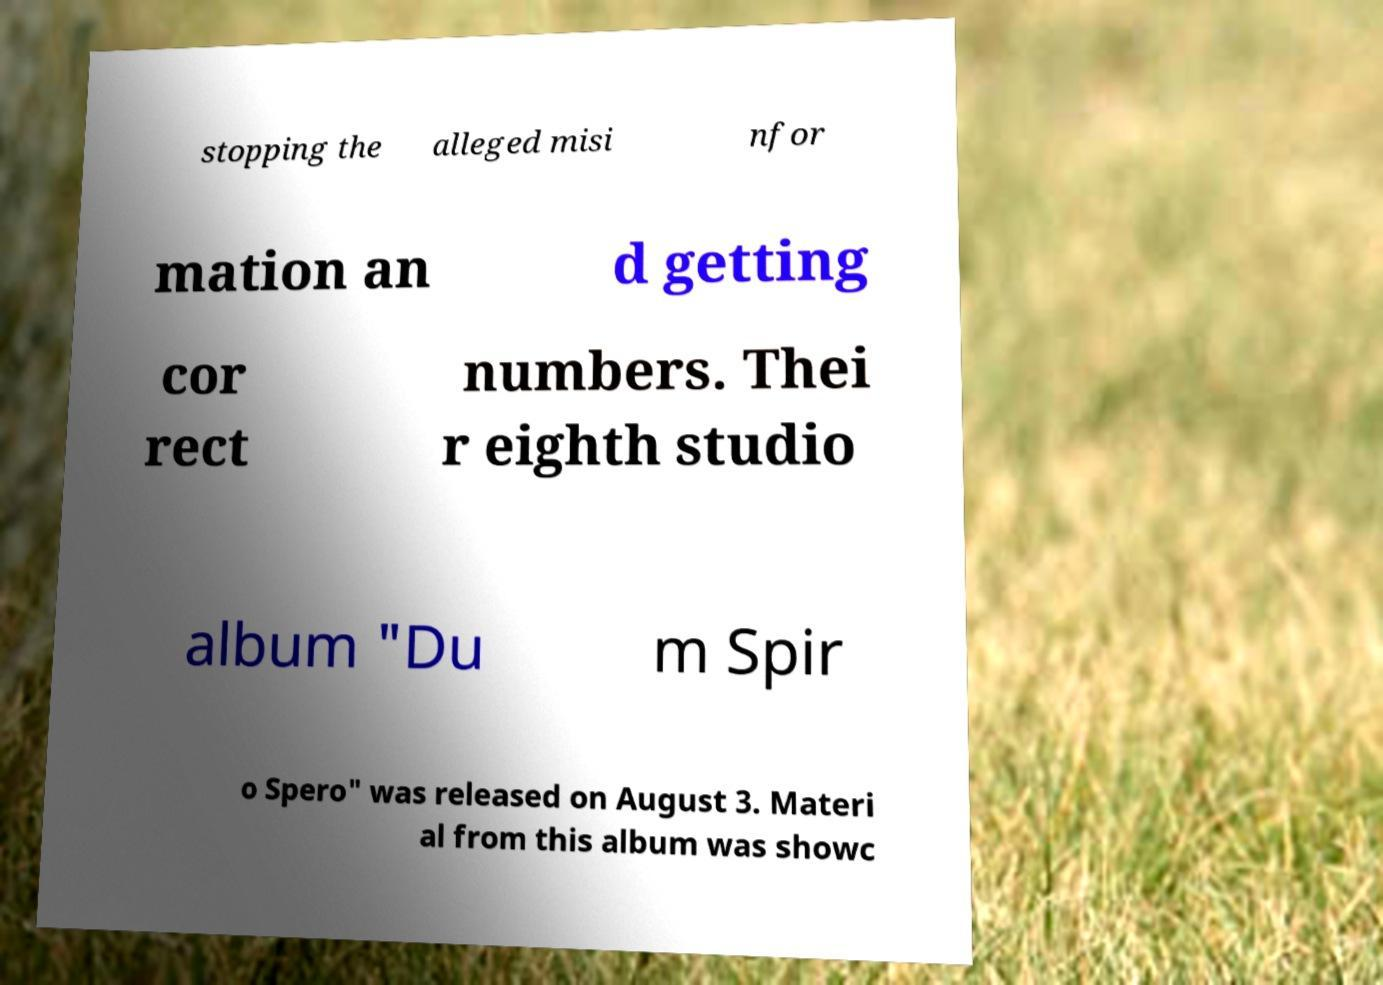Could you assist in decoding the text presented in this image and type it out clearly? stopping the alleged misi nfor mation an d getting cor rect numbers. Thei r eighth studio album "Du m Spir o Spero" was released on August 3. Materi al from this album was showc 